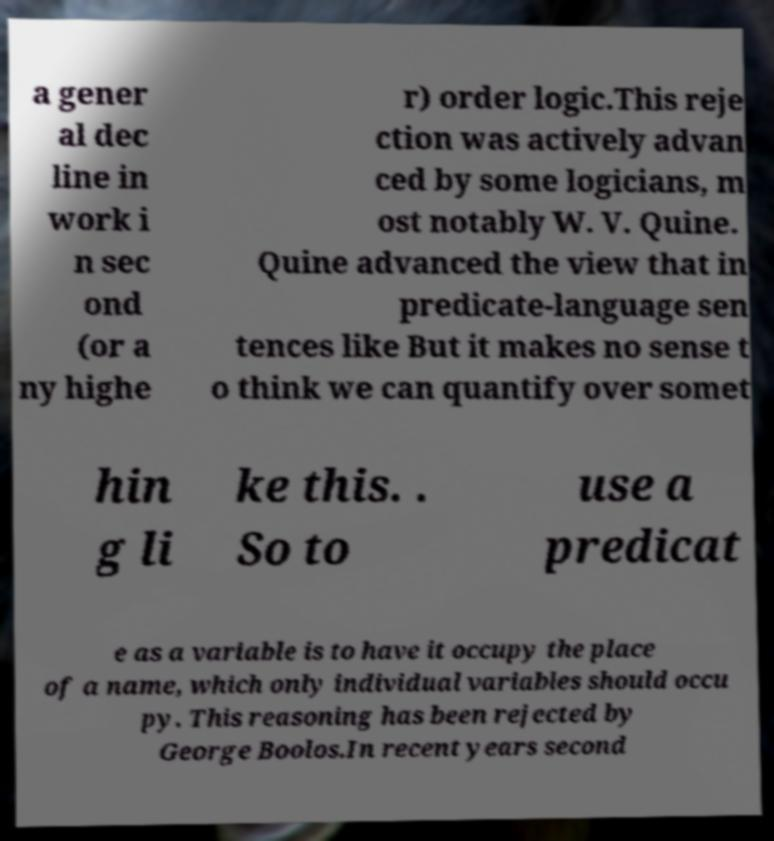Can you read and provide the text displayed in the image?This photo seems to have some interesting text. Can you extract and type it out for me? a gener al dec line in work i n sec ond (or a ny highe r) order logic.This reje ction was actively advan ced by some logicians, m ost notably W. V. Quine. Quine advanced the view that in predicate-language sen tences like But it makes no sense t o think we can quantify over somet hin g li ke this. . So to use a predicat e as a variable is to have it occupy the place of a name, which only individual variables should occu py. This reasoning has been rejected by George Boolos.In recent years second 